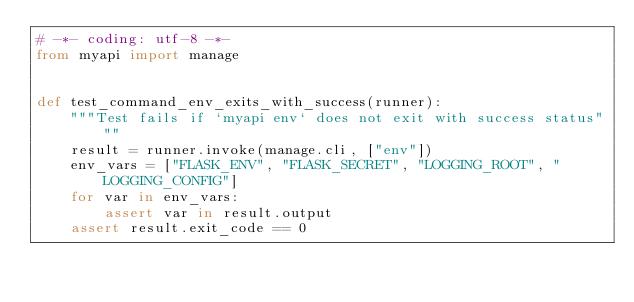<code> <loc_0><loc_0><loc_500><loc_500><_Python_># -*- coding: utf-8 -*-
from myapi import manage


def test_command_env_exits_with_success(runner):
    """Test fails if `myapi env` does not exit with success status"""
    result = runner.invoke(manage.cli, ["env"])
    env_vars = ["FLASK_ENV", "FLASK_SECRET", "LOGGING_ROOT", "LOGGING_CONFIG"]
    for var in env_vars:
        assert var in result.output
    assert result.exit_code == 0
</code> 